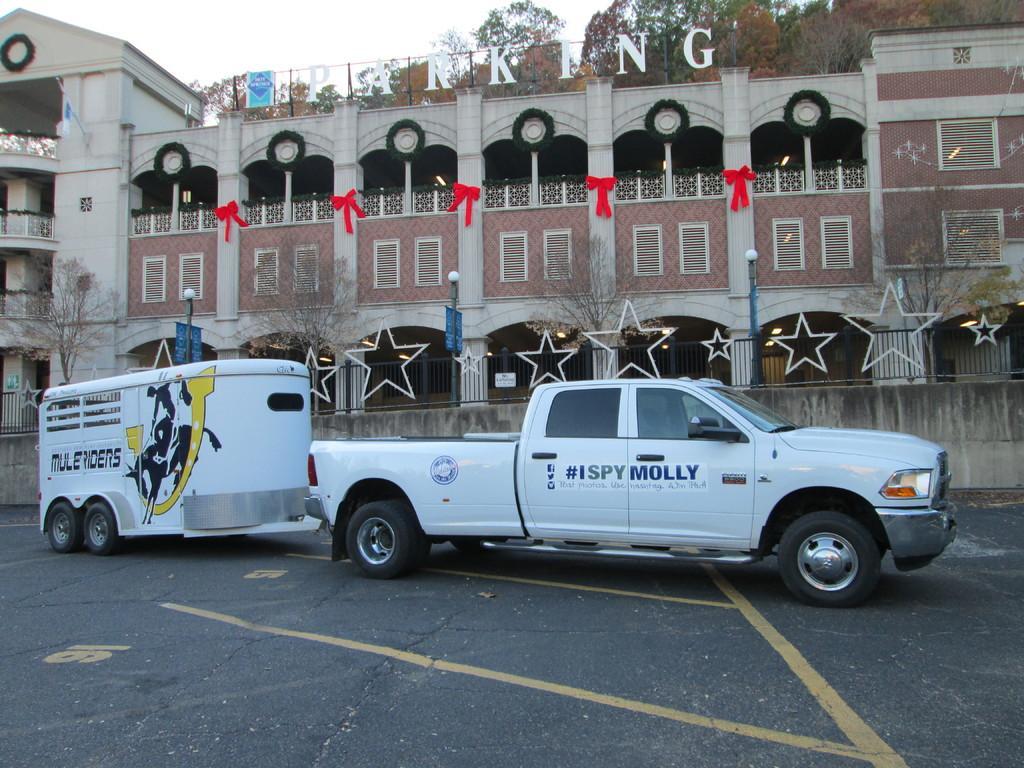Could you give a brief overview of what you see in this image? In this image we can see a building with some text written on it and we can also see vehicles, trees and sky. 